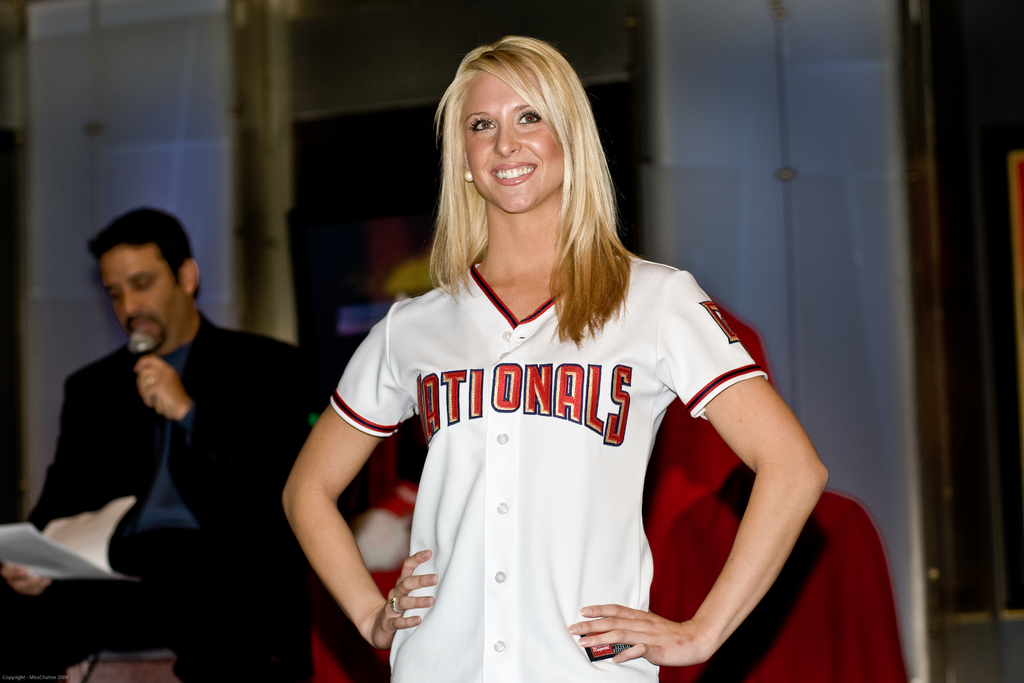Provide a one-sentence caption for the provided image. A smiling blonde woman confidently models a Washington Nationals jersey at a promotional event. 